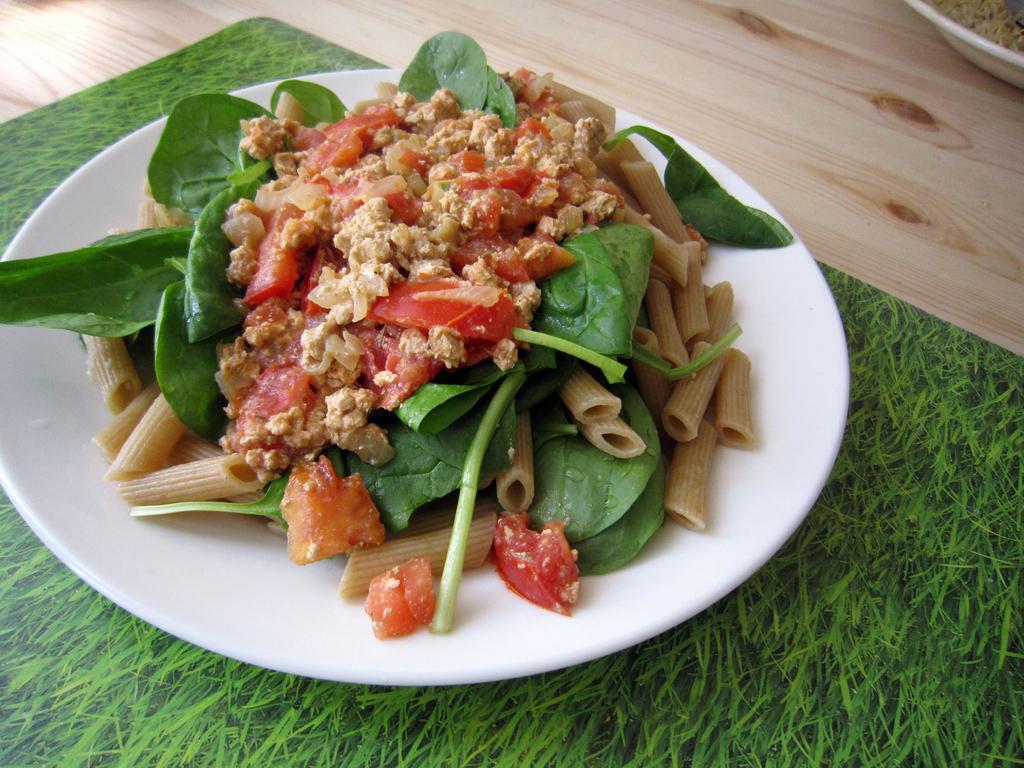Describe this image in one or two sentences. In this picture there are food items on the plates. There are plates and there is a board on the wooden floor. 